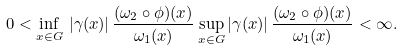Convert formula to latex. <formula><loc_0><loc_0><loc_500><loc_500>0 < \inf _ { x \in G } \, | \gamma ( x ) | \, \frac { ( \omega _ { 2 } \circ \phi ) ( x ) } { \omega _ { 1 } ( x ) } \sup _ { x \in G } | \gamma ( x ) | \, \frac { ( \omega _ { 2 } \circ \phi ) ( x ) } { \omega _ { 1 } ( x ) } < \infty .</formula> 